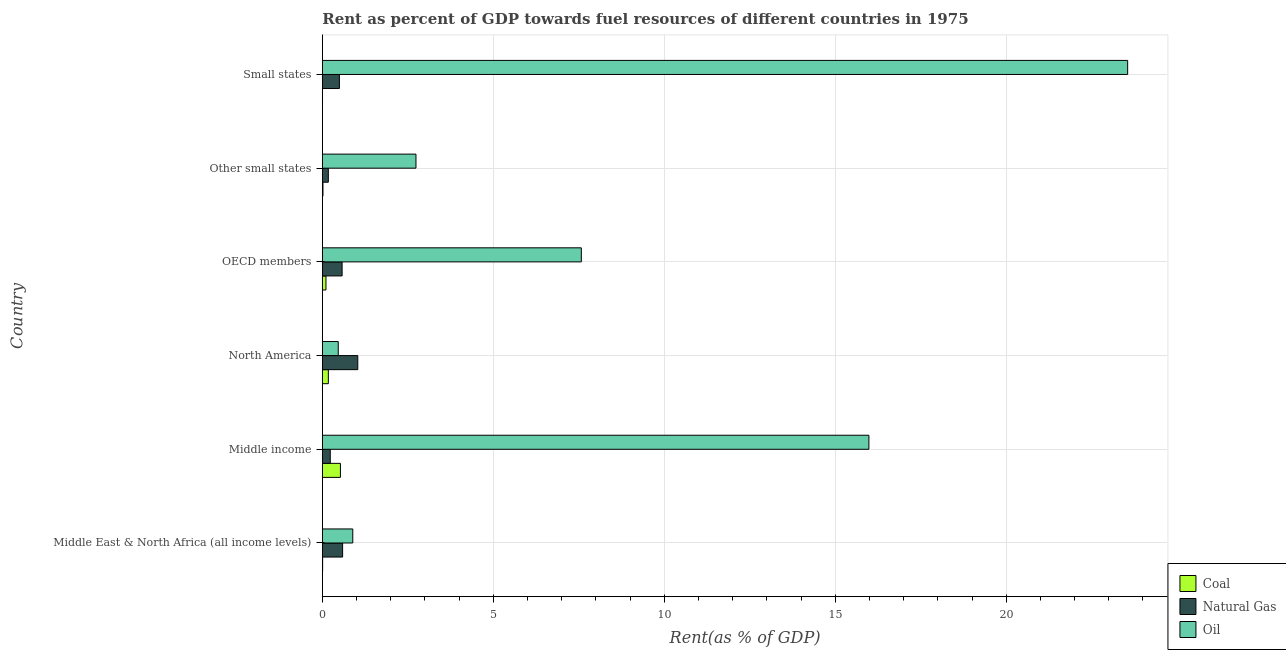How many different coloured bars are there?
Make the answer very short. 3. How many groups of bars are there?
Provide a succinct answer. 6. Are the number of bars on each tick of the Y-axis equal?
Offer a very short reply. Yes. How many bars are there on the 2nd tick from the top?
Your answer should be very brief. 3. How many bars are there on the 5th tick from the bottom?
Keep it short and to the point. 3. What is the label of the 2nd group of bars from the top?
Provide a short and direct response. Other small states. What is the rent towards natural gas in North America?
Give a very brief answer. 1.04. Across all countries, what is the maximum rent towards natural gas?
Your answer should be very brief. 1.04. Across all countries, what is the minimum rent towards natural gas?
Make the answer very short. 0.18. In which country was the rent towards natural gas maximum?
Offer a very short reply. North America. In which country was the rent towards coal minimum?
Offer a terse response. Small states. What is the total rent towards natural gas in the graph?
Provide a short and direct response. 3.11. What is the difference between the rent towards coal in OECD members and that in Small states?
Keep it short and to the point. 0.1. What is the difference between the rent towards natural gas in Middle East & North Africa (all income levels) and the rent towards coal in Other small states?
Your response must be concise. 0.57. What is the average rent towards natural gas per country?
Provide a short and direct response. 0.52. What is the difference between the rent towards oil and rent towards natural gas in Middle East & North Africa (all income levels)?
Offer a terse response. 0.3. What is the ratio of the rent towards coal in Middle East & North Africa (all income levels) to that in OECD members?
Your answer should be compact. 0.08. Is the rent towards natural gas in North America less than that in Other small states?
Provide a succinct answer. No. What is the difference between the highest and the second highest rent towards natural gas?
Keep it short and to the point. 0.44. What is the difference between the highest and the lowest rent towards coal?
Your answer should be very brief. 0.52. In how many countries, is the rent towards coal greater than the average rent towards coal taken over all countries?
Make the answer very short. 2. Is the sum of the rent towards oil in Middle income and Other small states greater than the maximum rent towards natural gas across all countries?
Provide a short and direct response. Yes. What does the 3rd bar from the top in North America represents?
Keep it short and to the point. Coal. What does the 2nd bar from the bottom in Other small states represents?
Offer a terse response. Natural Gas. Is it the case that in every country, the sum of the rent towards coal and rent towards natural gas is greater than the rent towards oil?
Offer a terse response. No. How many bars are there?
Ensure brevity in your answer.  18. How many countries are there in the graph?
Make the answer very short. 6. What is the difference between two consecutive major ticks on the X-axis?
Your answer should be compact. 5. Does the graph contain grids?
Your response must be concise. Yes. Where does the legend appear in the graph?
Your response must be concise. Bottom right. What is the title of the graph?
Offer a very short reply. Rent as percent of GDP towards fuel resources of different countries in 1975. What is the label or title of the X-axis?
Give a very brief answer. Rent(as % of GDP). What is the label or title of the Y-axis?
Your answer should be very brief. Country. What is the Rent(as % of GDP) of Coal in Middle East & North Africa (all income levels)?
Give a very brief answer. 0.01. What is the Rent(as % of GDP) of Natural Gas in Middle East & North Africa (all income levels)?
Provide a succinct answer. 0.59. What is the Rent(as % of GDP) of Oil in Middle East & North Africa (all income levels)?
Your answer should be compact. 0.89. What is the Rent(as % of GDP) of Coal in Middle income?
Provide a short and direct response. 0.53. What is the Rent(as % of GDP) in Natural Gas in Middle income?
Your answer should be compact. 0.23. What is the Rent(as % of GDP) in Oil in Middle income?
Provide a succinct answer. 15.99. What is the Rent(as % of GDP) in Coal in North America?
Your answer should be compact. 0.18. What is the Rent(as % of GDP) in Natural Gas in North America?
Your answer should be compact. 1.04. What is the Rent(as % of GDP) of Oil in North America?
Provide a succinct answer. 0.47. What is the Rent(as % of GDP) of Coal in OECD members?
Keep it short and to the point. 0.11. What is the Rent(as % of GDP) of Natural Gas in OECD members?
Offer a very short reply. 0.58. What is the Rent(as % of GDP) in Oil in OECD members?
Offer a very short reply. 7.57. What is the Rent(as % of GDP) in Coal in Other small states?
Ensure brevity in your answer.  0.02. What is the Rent(as % of GDP) of Natural Gas in Other small states?
Offer a terse response. 0.18. What is the Rent(as % of GDP) of Oil in Other small states?
Your answer should be very brief. 2.74. What is the Rent(as % of GDP) of Coal in Small states?
Your answer should be compact. 0.01. What is the Rent(as % of GDP) of Natural Gas in Small states?
Your answer should be very brief. 0.5. What is the Rent(as % of GDP) of Oil in Small states?
Ensure brevity in your answer.  23.55. Across all countries, what is the maximum Rent(as % of GDP) of Coal?
Offer a very short reply. 0.53. Across all countries, what is the maximum Rent(as % of GDP) of Natural Gas?
Your response must be concise. 1.04. Across all countries, what is the maximum Rent(as % of GDP) in Oil?
Provide a succinct answer. 23.55. Across all countries, what is the minimum Rent(as % of GDP) of Coal?
Offer a very short reply. 0.01. Across all countries, what is the minimum Rent(as % of GDP) of Natural Gas?
Keep it short and to the point. 0.18. Across all countries, what is the minimum Rent(as % of GDP) of Oil?
Give a very brief answer. 0.47. What is the total Rent(as % of GDP) in Coal in the graph?
Offer a terse response. 0.84. What is the total Rent(as % of GDP) in Natural Gas in the graph?
Make the answer very short. 3.11. What is the total Rent(as % of GDP) of Oil in the graph?
Provide a short and direct response. 51.21. What is the difference between the Rent(as % of GDP) in Coal in Middle East & North Africa (all income levels) and that in Middle income?
Keep it short and to the point. -0.52. What is the difference between the Rent(as % of GDP) in Natural Gas in Middle East & North Africa (all income levels) and that in Middle income?
Ensure brevity in your answer.  0.36. What is the difference between the Rent(as % of GDP) of Oil in Middle East & North Africa (all income levels) and that in Middle income?
Your response must be concise. -15.09. What is the difference between the Rent(as % of GDP) of Coal in Middle East & North Africa (all income levels) and that in North America?
Ensure brevity in your answer.  -0.17. What is the difference between the Rent(as % of GDP) in Natural Gas in Middle East & North Africa (all income levels) and that in North America?
Your answer should be very brief. -0.44. What is the difference between the Rent(as % of GDP) of Oil in Middle East & North Africa (all income levels) and that in North America?
Provide a succinct answer. 0.42. What is the difference between the Rent(as % of GDP) of Coal in Middle East & North Africa (all income levels) and that in OECD members?
Make the answer very short. -0.1. What is the difference between the Rent(as % of GDP) in Natural Gas in Middle East & North Africa (all income levels) and that in OECD members?
Keep it short and to the point. 0.01. What is the difference between the Rent(as % of GDP) of Oil in Middle East & North Africa (all income levels) and that in OECD members?
Ensure brevity in your answer.  -6.68. What is the difference between the Rent(as % of GDP) in Coal in Middle East & North Africa (all income levels) and that in Other small states?
Ensure brevity in your answer.  -0.01. What is the difference between the Rent(as % of GDP) in Natural Gas in Middle East & North Africa (all income levels) and that in Other small states?
Provide a succinct answer. 0.42. What is the difference between the Rent(as % of GDP) of Oil in Middle East & North Africa (all income levels) and that in Other small states?
Give a very brief answer. -1.85. What is the difference between the Rent(as % of GDP) of Coal in Middle East & North Africa (all income levels) and that in Small states?
Give a very brief answer. 0. What is the difference between the Rent(as % of GDP) of Natural Gas in Middle East & North Africa (all income levels) and that in Small states?
Give a very brief answer. 0.09. What is the difference between the Rent(as % of GDP) in Oil in Middle East & North Africa (all income levels) and that in Small states?
Your answer should be compact. -22.66. What is the difference between the Rent(as % of GDP) in Coal in Middle income and that in North America?
Your answer should be compact. 0.35. What is the difference between the Rent(as % of GDP) of Natural Gas in Middle income and that in North America?
Your answer should be very brief. -0.81. What is the difference between the Rent(as % of GDP) in Oil in Middle income and that in North America?
Give a very brief answer. 15.52. What is the difference between the Rent(as % of GDP) in Coal in Middle income and that in OECD members?
Give a very brief answer. 0.42. What is the difference between the Rent(as % of GDP) of Natural Gas in Middle income and that in OECD members?
Your answer should be compact. -0.35. What is the difference between the Rent(as % of GDP) of Oil in Middle income and that in OECD members?
Provide a short and direct response. 8.41. What is the difference between the Rent(as % of GDP) of Coal in Middle income and that in Other small states?
Make the answer very short. 0.51. What is the difference between the Rent(as % of GDP) in Natural Gas in Middle income and that in Other small states?
Provide a short and direct response. 0.06. What is the difference between the Rent(as % of GDP) of Oil in Middle income and that in Other small states?
Your answer should be compact. 13.25. What is the difference between the Rent(as % of GDP) of Coal in Middle income and that in Small states?
Give a very brief answer. 0.52. What is the difference between the Rent(as % of GDP) of Natural Gas in Middle income and that in Small states?
Offer a very short reply. -0.27. What is the difference between the Rent(as % of GDP) of Oil in Middle income and that in Small states?
Make the answer very short. -7.57. What is the difference between the Rent(as % of GDP) of Coal in North America and that in OECD members?
Keep it short and to the point. 0.07. What is the difference between the Rent(as % of GDP) in Natural Gas in North America and that in OECD members?
Your response must be concise. 0.46. What is the difference between the Rent(as % of GDP) of Oil in North America and that in OECD members?
Offer a very short reply. -7.11. What is the difference between the Rent(as % of GDP) of Coal in North America and that in Other small states?
Keep it short and to the point. 0.16. What is the difference between the Rent(as % of GDP) in Natural Gas in North America and that in Other small states?
Your response must be concise. 0.86. What is the difference between the Rent(as % of GDP) of Oil in North America and that in Other small states?
Make the answer very short. -2.27. What is the difference between the Rent(as % of GDP) in Coal in North America and that in Small states?
Provide a succinct answer. 0.17. What is the difference between the Rent(as % of GDP) in Natural Gas in North America and that in Small states?
Offer a terse response. 0.54. What is the difference between the Rent(as % of GDP) of Oil in North America and that in Small states?
Your response must be concise. -23.09. What is the difference between the Rent(as % of GDP) in Coal in OECD members and that in Other small states?
Provide a short and direct response. 0.09. What is the difference between the Rent(as % of GDP) of Natural Gas in OECD members and that in Other small states?
Give a very brief answer. 0.4. What is the difference between the Rent(as % of GDP) in Oil in OECD members and that in Other small states?
Keep it short and to the point. 4.84. What is the difference between the Rent(as % of GDP) in Coal in OECD members and that in Small states?
Make the answer very short. 0.1. What is the difference between the Rent(as % of GDP) of Natural Gas in OECD members and that in Small states?
Your answer should be very brief. 0.08. What is the difference between the Rent(as % of GDP) in Oil in OECD members and that in Small states?
Offer a very short reply. -15.98. What is the difference between the Rent(as % of GDP) in Coal in Other small states and that in Small states?
Give a very brief answer. 0.01. What is the difference between the Rent(as % of GDP) in Natural Gas in Other small states and that in Small states?
Your answer should be compact. -0.32. What is the difference between the Rent(as % of GDP) in Oil in Other small states and that in Small states?
Give a very brief answer. -20.81. What is the difference between the Rent(as % of GDP) in Coal in Middle East & North Africa (all income levels) and the Rent(as % of GDP) in Natural Gas in Middle income?
Give a very brief answer. -0.22. What is the difference between the Rent(as % of GDP) of Coal in Middle East & North Africa (all income levels) and the Rent(as % of GDP) of Oil in Middle income?
Your answer should be compact. -15.98. What is the difference between the Rent(as % of GDP) in Natural Gas in Middle East & North Africa (all income levels) and the Rent(as % of GDP) in Oil in Middle income?
Your answer should be compact. -15.39. What is the difference between the Rent(as % of GDP) in Coal in Middle East & North Africa (all income levels) and the Rent(as % of GDP) in Natural Gas in North America?
Give a very brief answer. -1.03. What is the difference between the Rent(as % of GDP) in Coal in Middle East & North Africa (all income levels) and the Rent(as % of GDP) in Oil in North America?
Offer a very short reply. -0.46. What is the difference between the Rent(as % of GDP) of Natural Gas in Middle East & North Africa (all income levels) and the Rent(as % of GDP) of Oil in North America?
Your response must be concise. 0.13. What is the difference between the Rent(as % of GDP) of Coal in Middle East & North Africa (all income levels) and the Rent(as % of GDP) of Natural Gas in OECD members?
Your response must be concise. -0.57. What is the difference between the Rent(as % of GDP) in Coal in Middle East & North Africa (all income levels) and the Rent(as % of GDP) in Oil in OECD members?
Keep it short and to the point. -7.57. What is the difference between the Rent(as % of GDP) in Natural Gas in Middle East & North Africa (all income levels) and the Rent(as % of GDP) in Oil in OECD members?
Offer a very short reply. -6.98. What is the difference between the Rent(as % of GDP) of Coal in Middle East & North Africa (all income levels) and the Rent(as % of GDP) of Natural Gas in Other small states?
Provide a succinct answer. -0.17. What is the difference between the Rent(as % of GDP) in Coal in Middle East & North Africa (all income levels) and the Rent(as % of GDP) in Oil in Other small states?
Your answer should be very brief. -2.73. What is the difference between the Rent(as % of GDP) in Natural Gas in Middle East & North Africa (all income levels) and the Rent(as % of GDP) in Oil in Other small states?
Offer a terse response. -2.15. What is the difference between the Rent(as % of GDP) in Coal in Middle East & North Africa (all income levels) and the Rent(as % of GDP) in Natural Gas in Small states?
Your answer should be very brief. -0.49. What is the difference between the Rent(as % of GDP) of Coal in Middle East & North Africa (all income levels) and the Rent(as % of GDP) of Oil in Small states?
Ensure brevity in your answer.  -23.54. What is the difference between the Rent(as % of GDP) of Natural Gas in Middle East & North Africa (all income levels) and the Rent(as % of GDP) of Oil in Small states?
Provide a short and direct response. -22.96. What is the difference between the Rent(as % of GDP) of Coal in Middle income and the Rent(as % of GDP) of Natural Gas in North America?
Your answer should be compact. -0.51. What is the difference between the Rent(as % of GDP) in Coal in Middle income and the Rent(as % of GDP) in Oil in North America?
Provide a short and direct response. 0.06. What is the difference between the Rent(as % of GDP) of Natural Gas in Middle income and the Rent(as % of GDP) of Oil in North America?
Offer a very short reply. -0.23. What is the difference between the Rent(as % of GDP) of Coal in Middle income and the Rent(as % of GDP) of Natural Gas in OECD members?
Your response must be concise. -0.05. What is the difference between the Rent(as % of GDP) in Coal in Middle income and the Rent(as % of GDP) in Oil in OECD members?
Give a very brief answer. -7.05. What is the difference between the Rent(as % of GDP) in Natural Gas in Middle income and the Rent(as % of GDP) in Oil in OECD members?
Offer a very short reply. -7.34. What is the difference between the Rent(as % of GDP) of Coal in Middle income and the Rent(as % of GDP) of Natural Gas in Other small states?
Your answer should be very brief. 0.35. What is the difference between the Rent(as % of GDP) of Coal in Middle income and the Rent(as % of GDP) of Oil in Other small states?
Your response must be concise. -2.21. What is the difference between the Rent(as % of GDP) of Natural Gas in Middle income and the Rent(as % of GDP) of Oil in Other small states?
Offer a very short reply. -2.51. What is the difference between the Rent(as % of GDP) in Coal in Middle income and the Rent(as % of GDP) in Natural Gas in Small states?
Provide a short and direct response. 0.03. What is the difference between the Rent(as % of GDP) in Coal in Middle income and the Rent(as % of GDP) in Oil in Small states?
Provide a succinct answer. -23.02. What is the difference between the Rent(as % of GDP) of Natural Gas in Middle income and the Rent(as % of GDP) of Oil in Small states?
Your response must be concise. -23.32. What is the difference between the Rent(as % of GDP) in Coal in North America and the Rent(as % of GDP) in Natural Gas in OECD members?
Provide a succinct answer. -0.4. What is the difference between the Rent(as % of GDP) of Coal in North America and the Rent(as % of GDP) of Oil in OECD members?
Your answer should be compact. -7.4. What is the difference between the Rent(as % of GDP) of Natural Gas in North America and the Rent(as % of GDP) of Oil in OECD members?
Give a very brief answer. -6.54. What is the difference between the Rent(as % of GDP) in Coal in North America and the Rent(as % of GDP) in Natural Gas in Other small states?
Keep it short and to the point. 0. What is the difference between the Rent(as % of GDP) of Coal in North America and the Rent(as % of GDP) of Oil in Other small states?
Offer a very short reply. -2.56. What is the difference between the Rent(as % of GDP) in Natural Gas in North America and the Rent(as % of GDP) in Oil in Other small states?
Provide a succinct answer. -1.7. What is the difference between the Rent(as % of GDP) in Coal in North America and the Rent(as % of GDP) in Natural Gas in Small states?
Your answer should be compact. -0.32. What is the difference between the Rent(as % of GDP) in Coal in North America and the Rent(as % of GDP) in Oil in Small states?
Offer a terse response. -23.38. What is the difference between the Rent(as % of GDP) in Natural Gas in North America and the Rent(as % of GDP) in Oil in Small states?
Offer a very short reply. -22.52. What is the difference between the Rent(as % of GDP) in Coal in OECD members and the Rent(as % of GDP) in Natural Gas in Other small states?
Offer a terse response. -0.07. What is the difference between the Rent(as % of GDP) of Coal in OECD members and the Rent(as % of GDP) of Oil in Other small states?
Provide a short and direct response. -2.63. What is the difference between the Rent(as % of GDP) of Natural Gas in OECD members and the Rent(as % of GDP) of Oil in Other small states?
Provide a short and direct response. -2.16. What is the difference between the Rent(as % of GDP) in Coal in OECD members and the Rent(as % of GDP) in Natural Gas in Small states?
Offer a terse response. -0.39. What is the difference between the Rent(as % of GDP) in Coal in OECD members and the Rent(as % of GDP) in Oil in Small states?
Offer a very short reply. -23.45. What is the difference between the Rent(as % of GDP) of Natural Gas in OECD members and the Rent(as % of GDP) of Oil in Small states?
Make the answer very short. -22.97. What is the difference between the Rent(as % of GDP) of Coal in Other small states and the Rent(as % of GDP) of Natural Gas in Small states?
Give a very brief answer. -0.48. What is the difference between the Rent(as % of GDP) of Coal in Other small states and the Rent(as % of GDP) of Oil in Small states?
Offer a very short reply. -23.53. What is the difference between the Rent(as % of GDP) of Natural Gas in Other small states and the Rent(as % of GDP) of Oil in Small states?
Offer a terse response. -23.38. What is the average Rent(as % of GDP) of Coal per country?
Ensure brevity in your answer.  0.14. What is the average Rent(as % of GDP) of Natural Gas per country?
Ensure brevity in your answer.  0.52. What is the average Rent(as % of GDP) of Oil per country?
Give a very brief answer. 8.53. What is the difference between the Rent(as % of GDP) in Coal and Rent(as % of GDP) in Natural Gas in Middle East & North Africa (all income levels)?
Keep it short and to the point. -0.58. What is the difference between the Rent(as % of GDP) in Coal and Rent(as % of GDP) in Oil in Middle East & North Africa (all income levels)?
Ensure brevity in your answer.  -0.88. What is the difference between the Rent(as % of GDP) in Natural Gas and Rent(as % of GDP) in Oil in Middle East & North Africa (all income levels)?
Provide a succinct answer. -0.3. What is the difference between the Rent(as % of GDP) in Coal and Rent(as % of GDP) in Natural Gas in Middle income?
Your response must be concise. 0.3. What is the difference between the Rent(as % of GDP) of Coal and Rent(as % of GDP) of Oil in Middle income?
Provide a short and direct response. -15.46. What is the difference between the Rent(as % of GDP) in Natural Gas and Rent(as % of GDP) in Oil in Middle income?
Give a very brief answer. -15.75. What is the difference between the Rent(as % of GDP) of Coal and Rent(as % of GDP) of Natural Gas in North America?
Make the answer very short. -0.86. What is the difference between the Rent(as % of GDP) in Coal and Rent(as % of GDP) in Oil in North America?
Provide a succinct answer. -0.29. What is the difference between the Rent(as % of GDP) in Natural Gas and Rent(as % of GDP) in Oil in North America?
Keep it short and to the point. 0.57. What is the difference between the Rent(as % of GDP) of Coal and Rent(as % of GDP) of Natural Gas in OECD members?
Your answer should be compact. -0.47. What is the difference between the Rent(as % of GDP) in Coal and Rent(as % of GDP) in Oil in OECD members?
Your response must be concise. -7.47. What is the difference between the Rent(as % of GDP) of Natural Gas and Rent(as % of GDP) of Oil in OECD members?
Offer a terse response. -7. What is the difference between the Rent(as % of GDP) of Coal and Rent(as % of GDP) of Natural Gas in Other small states?
Provide a succinct answer. -0.16. What is the difference between the Rent(as % of GDP) of Coal and Rent(as % of GDP) of Oil in Other small states?
Keep it short and to the point. -2.72. What is the difference between the Rent(as % of GDP) in Natural Gas and Rent(as % of GDP) in Oil in Other small states?
Your response must be concise. -2.56. What is the difference between the Rent(as % of GDP) in Coal and Rent(as % of GDP) in Natural Gas in Small states?
Offer a terse response. -0.49. What is the difference between the Rent(as % of GDP) of Coal and Rent(as % of GDP) of Oil in Small states?
Offer a terse response. -23.55. What is the difference between the Rent(as % of GDP) of Natural Gas and Rent(as % of GDP) of Oil in Small states?
Your answer should be compact. -23.05. What is the ratio of the Rent(as % of GDP) of Coal in Middle East & North Africa (all income levels) to that in Middle income?
Provide a short and direct response. 0.02. What is the ratio of the Rent(as % of GDP) in Natural Gas in Middle East & North Africa (all income levels) to that in Middle income?
Your response must be concise. 2.56. What is the ratio of the Rent(as % of GDP) of Oil in Middle East & North Africa (all income levels) to that in Middle income?
Offer a terse response. 0.06. What is the ratio of the Rent(as % of GDP) of Coal in Middle East & North Africa (all income levels) to that in North America?
Provide a succinct answer. 0.05. What is the ratio of the Rent(as % of GDP) of Natural Gas in Middle East & North Africa (all income levels) to that in North America?
Your response must be concise. 0.57. What is the ratio of the Rent(as % of GDP) of Oil in Middle East & North Africa (all income levels) to that in North America?
Your response must be concise. 1.91. What is the ratio of the Rent(as % of GDP) of Coal in Middle East & North Africa (all income levels) to that in OECD members?
Ensure brevity in your answer.  0.08. What is the ratio of the Rent(as % of GDP) of Natural Gas in Middle East & North Africa (all income levels) to that in OECD members?
Provide a short and direct response. 1.03. What is the ratio of the Rent(as % of GDP) of Oil in Middle East & North Africa (all income levels) to that in OECD members?
Provide a succinct answer. 0.12. What is the ratio of the Rent(as % of GDP) of Coal in Middle East & North Africa (all income levels) to that in Other small states?
Give a very brief answer. 0.47. What is the ratio of the Rent(as % of GDP) in Natural Gas in Middle East & North Africa (all income levels) to that in Other small states?
Ensure brevity in your answer.  3.38. What is the ratio of the Rent(as % of GDP) in Oil in Middle East & North Africa (all income levels) to that in Other small states?
Ensure brevity in your answer.  0.33. What is the ratio of the Rent(as % of GDP) of Coal in Middle East & North Africa (all income levels) to that in Small states?
Offer a very short reply. 1.57. What is the ratio of the Rent(as % of GDP) of Natural Gas in Middle East & North Africa (all income levels) to that in Small states?
Your answer should be compact. 1.19. What is the ratio of the Rent(as % of GDP) of Oil in Middle East & North Africa (all income levels) to that in Small states?
Your answer should be very brief. 0.04. What is the ratio of the Rent(as % of GDP) of Coal in Middle income to that in North America?
Your response must be concise. 3.01. What is the ratio of the Rent(as % of GDP) of Natural Gas in Middle income to that in North America?
Your response must be concise. 0.22. What is the ratio of the Rent(as % of GDP) in Oil in Middle income to that in North America?
Give a very brief answer. 34.33. What is the ratio of the Rent(as % of GDP) of Coal in Middle income to that in OECD members?
Provide a short and direct response. 4.97. What is the ratio of the Rent(as % of GDP) of Natural Gas in Middle income to that in OECD members?
Provide a short and direct response. 0.4. What is the ratio of the Rent(as % of GDP) of Oil in Middle income to that in OECD members?
Keep it short and to the point. 2.11. What is the ratio of the Rent(as % of GDP) of Coal in Middle income to that in Other small states?
Keep it short and to the point. 28.54. What is the ratio of the Rent(as % of GDP) of Natural Gas in Middle income to that in Other small states?
Offer a terse response. 1.32. What is the ratio of the Rent(as % of GDP) of Oil in Middle income to that in Other small states?
Your answer should be compact. 5.84. What is the ratio of the Rent(as % of GDP) of Coal in Middle income to that in Small states?
Provide a short and direct response. 96.22. What is the ratio of the Rent(as % of GDP) in Natural Gas in Middle income to that in Small states?
Your response must be concise. 0.47. What is the ratio of the Rent(as % of GDP) of Oil in Middle income to that in Small states?
Provide a short and direct response. 0.68. What is the ratio of the Rent(as % of GDP) in Coal in North America to that in OECD members?
Keep it short and to the point. 1.65. What is the ratio of the Rent(as % of GDP) of Natural Gas in North America to that in OECD members?
Ensure brevity in your answer.  1.79. What is the ratio of the Rent(as % of GDP) in Oil in North America to that in OECD members?
Make the answer very short. 0.06. What is the ratio of the Rent(as % of GDP) of Coal in North America to that in Other small states?
Your answer should be compact. 9.49. What is the ratio of the Rent(as % of GDP) of Natural Gas in North America to that in Other small states?
Offer a very short reply. 5.9. What is the ratio of the Rent(as % of GDP) of Oil in North America to that in Other small states?
Provide a short and direct response. 0.17. What is the ratio of the Rent(as % of GDP) in Coal in North America to that in Small states?
Your answer should be very brief. 32.01. What is the ratio of the Rent(as % of GDP) in Natural Gas in North America to that in Small states?
Your answer should be very brief. 2.08. What is the ratio of the Rent(as % of GDP) of Oil in North America to that in Small states?
Give a very brief answer. 0.02. What is the ratio of the Rent(as % of GDP) in Coal in OECD members to that in Other small states?
Your answer should be compact. 5.75. What is the ratio of the Rent(as % of GDP) in Natural Gas in OECD members to that in Other small states?
Offer a very short reply. 3.29. What is the ratio of the Rent(as % of GDP) of Oil in OECD members to that in Other small states?
Offer a very short reply. 2.77. What is the ratio of the Rent(as % of GDP) of Coal in OECD members to that in Small states?
Ensure brevity in your answer.  19.37. What is the ratio of the Rent(as % of GDP) of Natural Gas in OECD members to that in Small states?
Keep it short and to the point. 1.16. What is the ratio of the Rent(as % of GDP) of Oil in OECD members to that in Small states?
Offer a terse response. 0.32. What is the ratio of the Rent(as % of GDP) in Coal in Other small states to that in Small states?
Your answer should be very brief. 3.37. What is the ratio of the Rent(as % of GDP) of Natural Gas in Other small states to that in Small states?
Make the answer very short. 0.35. What is the ratio of the Rent(as % of GDP) of Oil in Other small states to that in Small states?
Offer a very short reply. 0.12. What is the difference between the highest and the second highest Rent(as % of GDP) in Coal?
Ensure brevity in your answer.  0.35. What is the difference between the highest and the second highest Rent(as % of GDP) of Natural Gas?
Your answer should be compact. 0.44. What is the difference between the highest and the second highest Rent(as % of GDP) in Oil?
Provide a short and direct response. 7.57. What is the difference between the highest and the lowest Rent(as % of GDP) of Coal?
Offer a terse response. 0.52. What is the difference between the highest and the lowest Rent(as % of GDP) in Natural Gas?
Give a very brief answer. 0.86. What is the difference between the highest and the lowest Rent(as % of GDP) of Oil?
Offer a terse response. 23.09. 